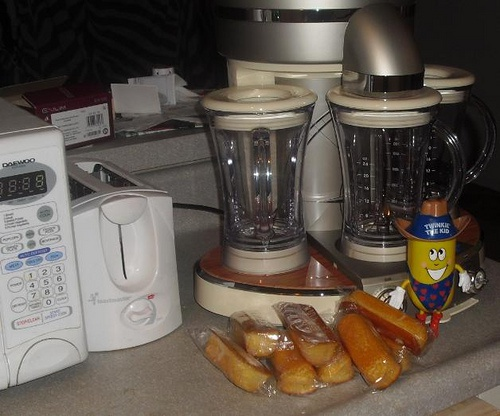Describe the objects in this image and their specific colors. I can see microwave in black, darkgray, gray, and lightgray tones and toaster in black, darkgray, gray, and lightgray tones in this image. 